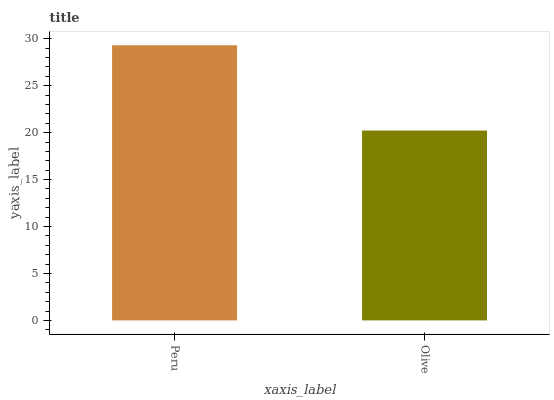Is Olive the minimum?
Answer yes or no. Yes. Is Peru the maximum?
Answer yes or no. Yes. Is Olive the maximum?
Answer yes or no. No. Is Peru greater than Olive?
Answer yes or no. Yes. Is Olive less than Peru?
Answer yes or no. Yes. Is Olive greater than Peru?
Answer yes or no. No. Is Peru less than Olive?
Answer yes or no. No. Is Peru the high median?
Answer yes or no. Yes. Is Olive the low median?
Answer yes or no. Yes. Is Olive the high median?
Answer yes or no. No. Is Peru the low median?
Answer yes or no. No. 